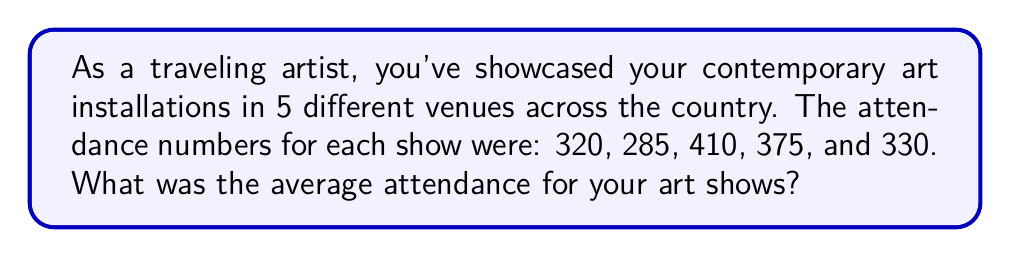What is the answer to this math problem? To find the average attendance, we need to follow these steps:

1. Add up all the attendance numbers:
   $320 + 285 + 410 + 375 + 330 = 1720$

2. Count the total number of shows:
   There were 5 shows in total.

3. Divide the sum of attendance by the number of shows:
   $\text{Average} = \frac{\text{Sum of attendance}}{\text{Number of shows}}$
   
   $\text{Average} = \frac{1720}{5}$

4. Perform the division:
   $\text{Average} = 344$

Therefore, the average attendance for your art shows was 344 people.
Answer: 344 people 